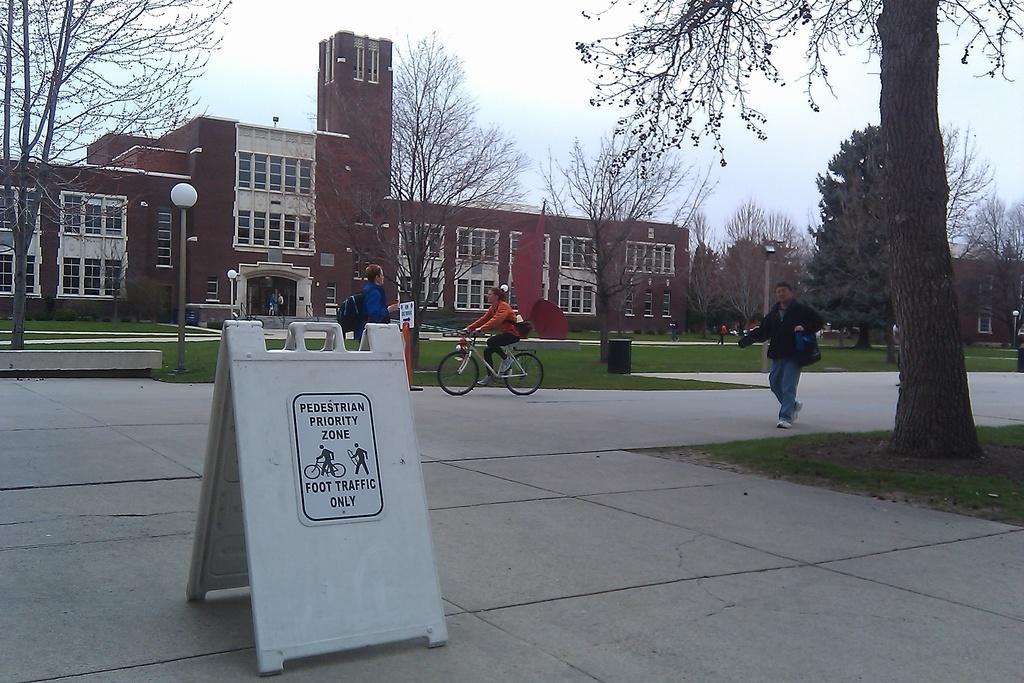In one or two sentences, can you explain what this image depicts? In this image, we can see a few buildings. We can see some people. There are a few trees. We can see the ground. We can see some grass, poles. We can also see a red colored object. We can see the sky. 